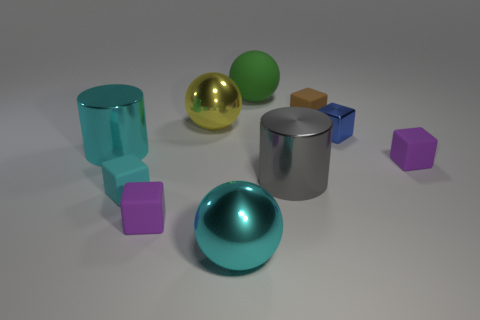Subtract all purple cubes. How many were subtracted if there are1purple cubes left? 1 Subtract all small brown matte blocks. How many blocks are left? 4 Subtract 2 purple blocks. How many objects are left? 8 Subtract all cylinders. How many objects are left? 8 Subtract 1 blocks. How many blocks are left? 4 Subtract all yellow cylinders. Subtract all purple blocks. How many cylinders are left? 2 Subtract all brown spheres. How many cyan cylinders are left? 1 Subtract all purple cubes. Subtract all green things. How many objects are left? 7 Add 8 purple rubber objects. How many purple rubber objects are left? 10 Add 1 big gray metal cylinders. How many big gray metal cylinders exist? 2 